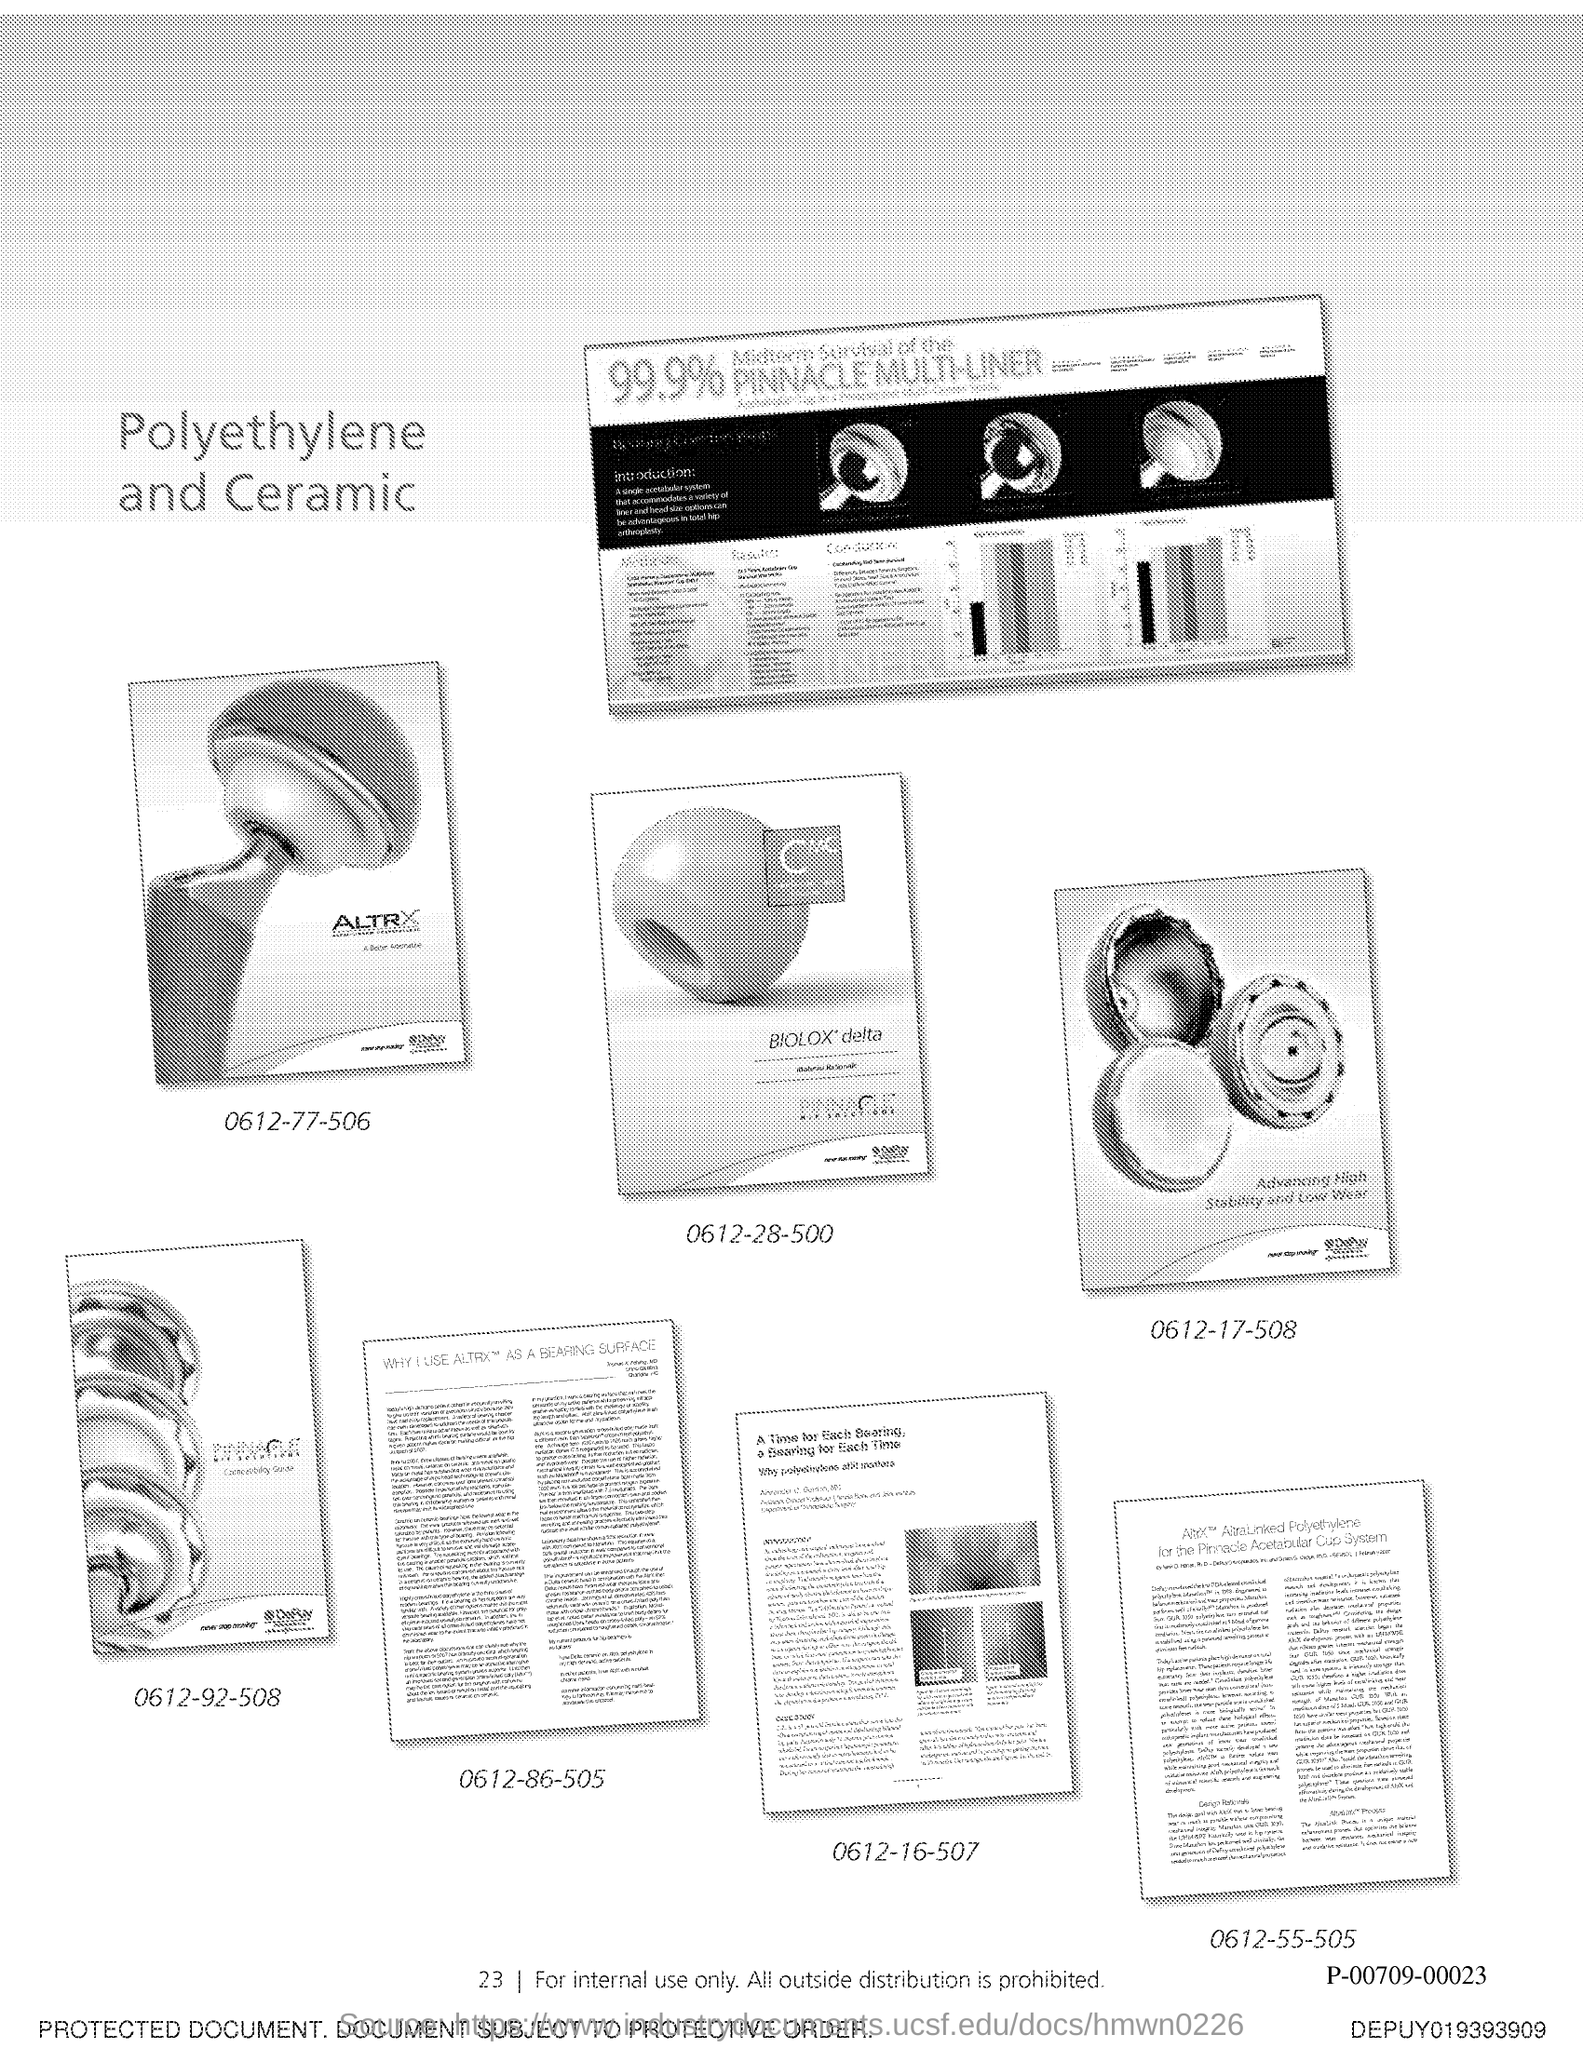Give some essential details in this illustration. The page number is 23. 